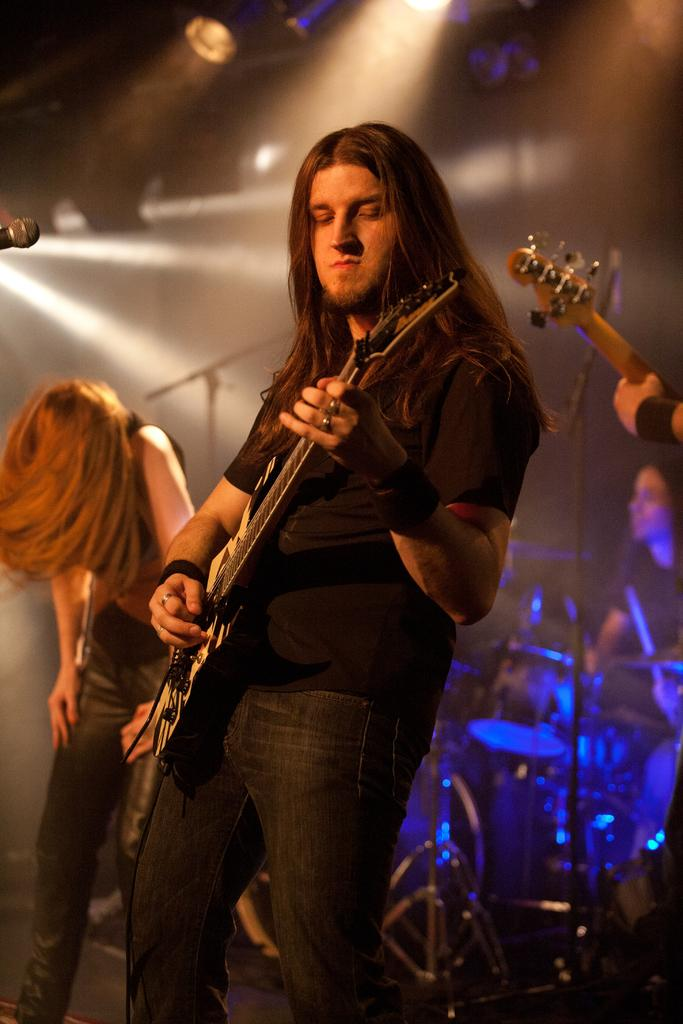What is happening in the image? There are people on stage in the image. What is the man on stage holding? The man on stage is holding a guitar. What other musical instruments can be seen on stage? There are musical drums behind the man on stage. How many fans are visible in the image? There are no fans visible in the image. What is the grandfather doing on stage? There is no mention of a grandfather in the image, and no one is depicted as doing anything on stage besides the man holding the guitar. 